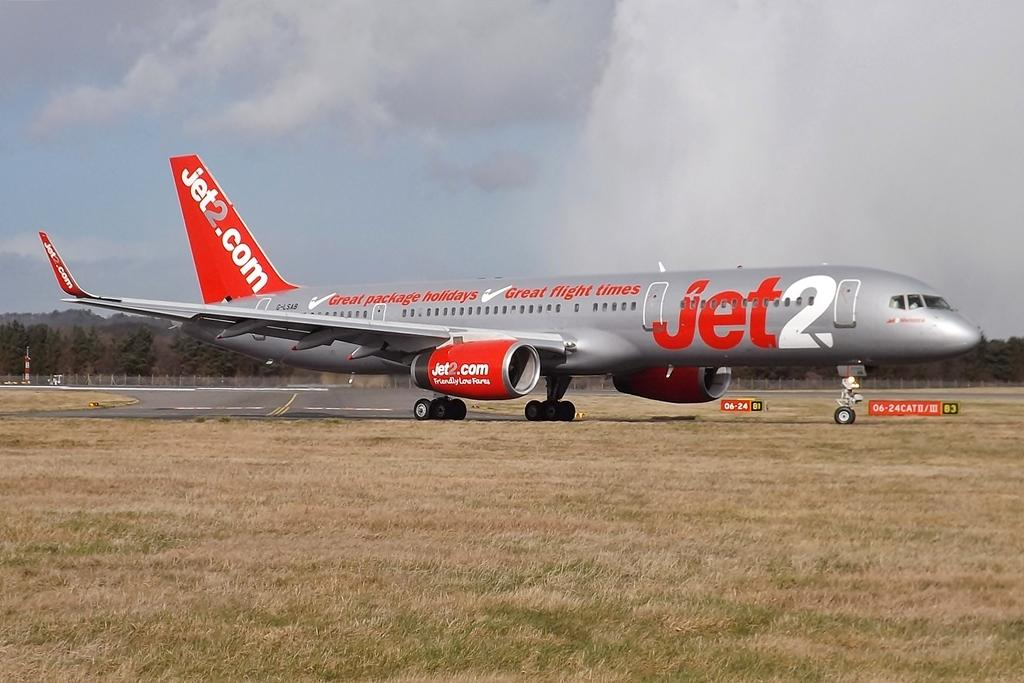<image>
Share a concise interpretation of the image provided. A Jet2 airplane is sitting on a runway by a field of dry grass. 